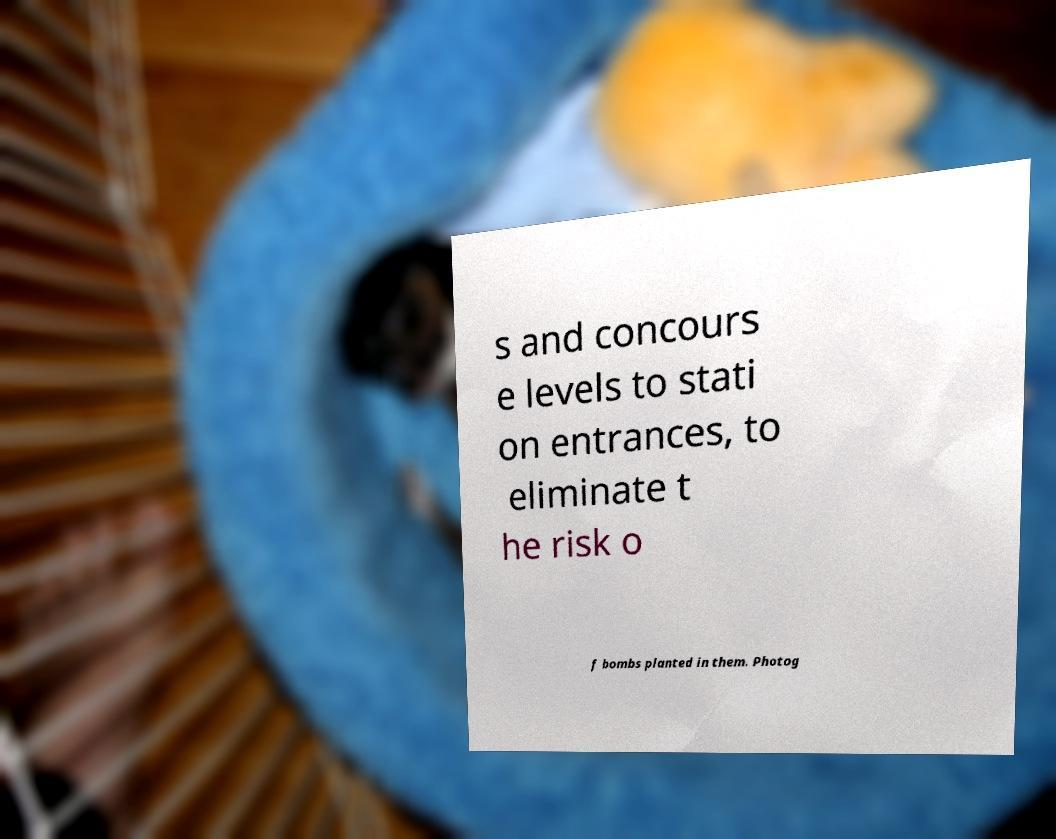What messages or text are displayed in this image? I need them in a readable, typed format. s and concours e levels to stati on entrances, to eliminate t he risk o f bombs planted in them. Photog 